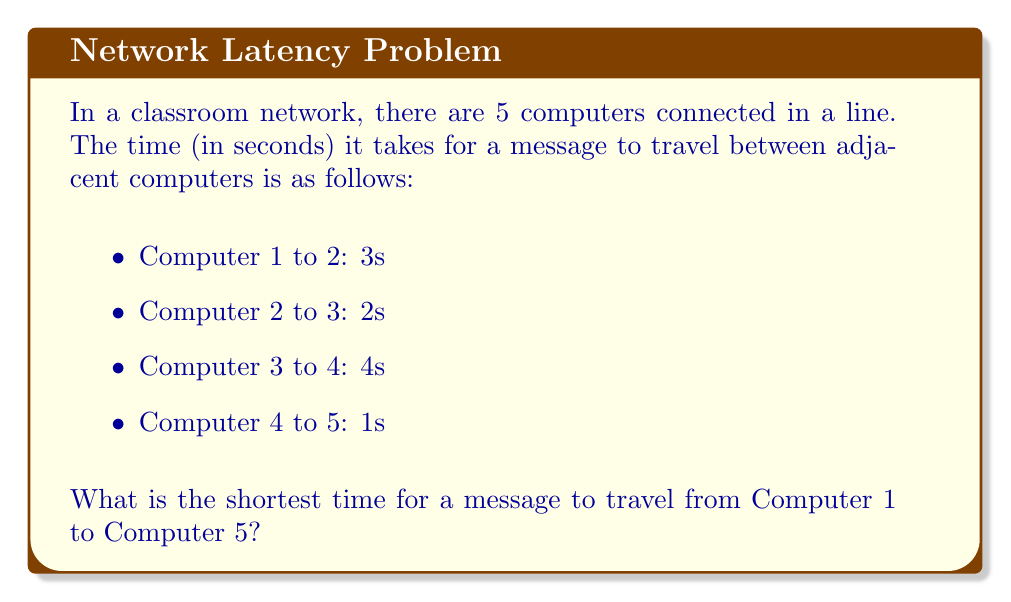Show me your answer to this math problem. To solve this problem, we need to add up the time it takes for the message to travel between each pair of adjacent computers. This is because the message must pass through each computer in the line to reach the final destination.

Step 1: Identify the path
The path from Computer 1 to Computer 5 is:
1 → 2 → 3 → 4 → 5

Step 2: Add up the travel times
Let's add the time for each segment:
* Computer 1 to 2: 3s
* Computer 2 to 3: 2s
* Computer 3 to 4: 4s
* Computer 4 to 5: 1s

Total time = 3s + 2s + 4s + 1s

Step 3: Calculate the total
$$ \text{Total time} = 3 + 2 + 4 + 1 = 10\text{ seconds} $$

Therefore, the shortest time for a message to travel from Computer 1 to Computer 5 is 10 seconds.

This problem demonstrates how data travels through a network and how the total transmission time is calculated, which is relevant to finding efficient paths in networks.
Answer: 10 seconds 